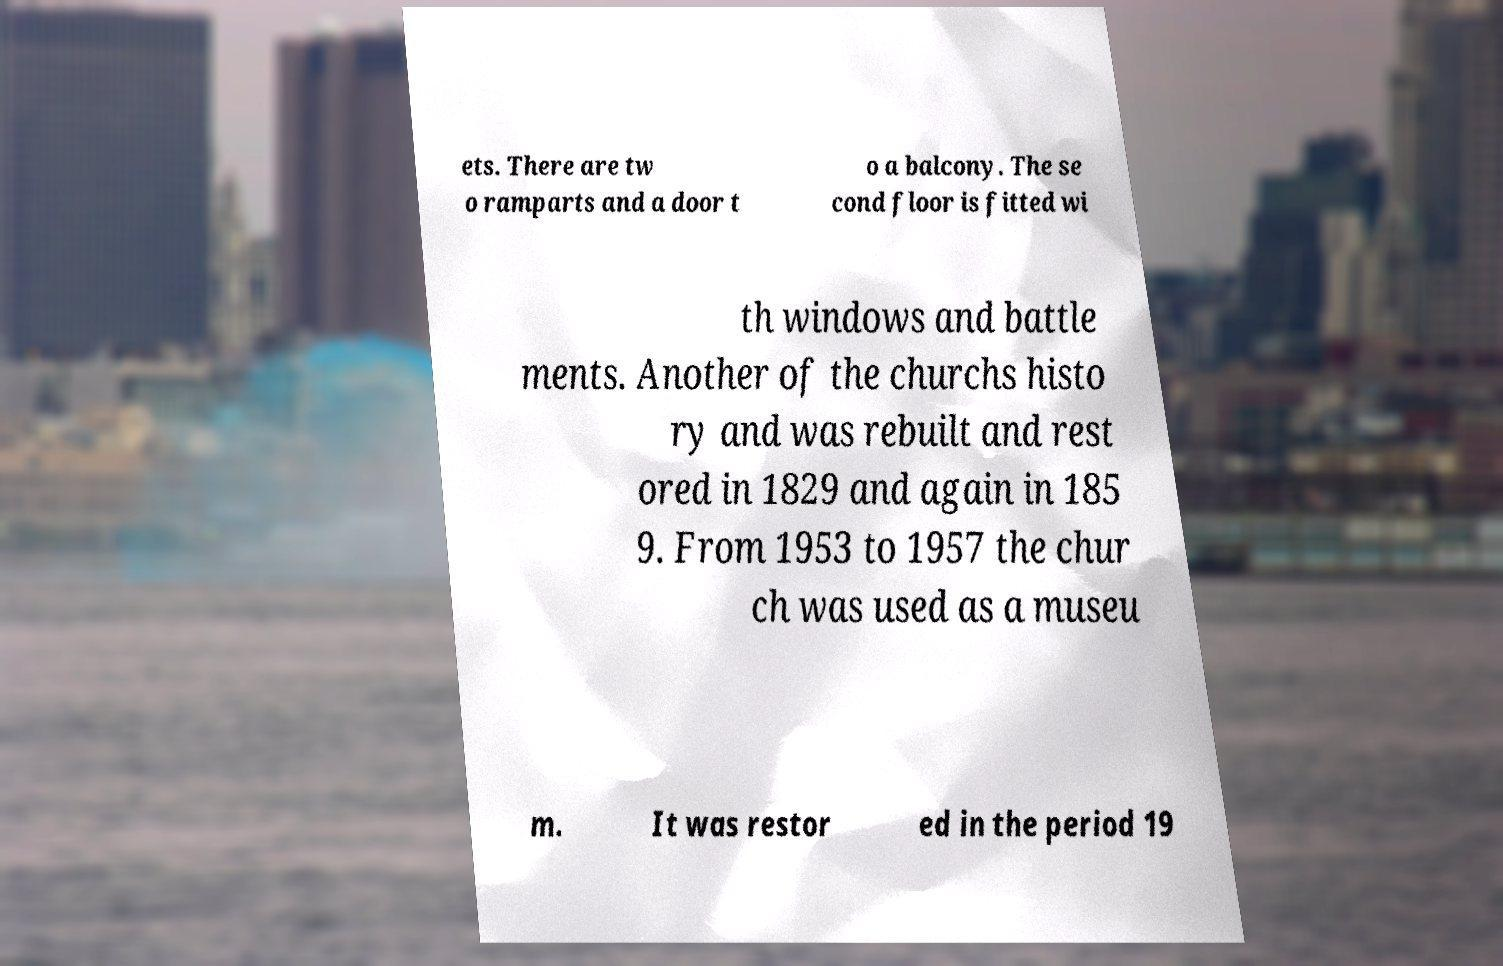What messages or text are displayed in this image? I need them in a readable, typed format. ets. There are tw o ramparts and a door t o a balcony. The se cond floor is fitted wi th windows and battle ments. Another of the churchs histo ry and was rebuilt and rest ored in 1829 and again in 185 9. From 1953 to 1957 the chur ch was used as a museu m. It was restor ed in the period 19 